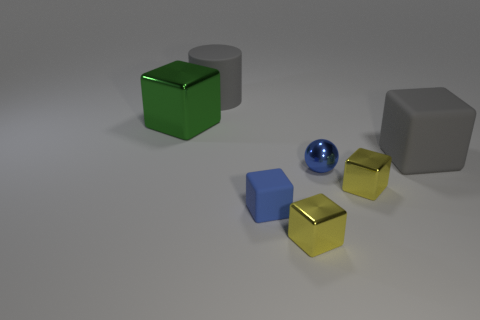What is the material of the gray cylinder that is the same size as the gray block?
Offer a terse response. Rubber. What number of other things are made of the same material as the tiny blue sphere?
Provide a short and direct response. 3. Is the number of yellow shiny cubes that are behind the big shiny cube less than the number of large cylinders?
Your answer should be compact. Yes. Is the shape of the tiny matte object the same as the large shiny thing?
Your response must be concise. Yes. How big is the object that is behind the block that is on the left side of the big gray matte object on the left side of the large gray rubber cube?
Offer a very short reply. Large. What is the material of the other big object that is the same shape as the big green object?
Offer a very short reply. Rubber. Is there anything else that is the same size as the ball?
Provide a short and direct response. Yes. What size is the gray matte object that is on the right side of the large gray thing that is behind the big green metallic object?
Your answer should be very brief. Large. What is the color of the small sphere?
Give a very brief answer. Blue. What number of blue things are behind the small blue object on the left side of the blue metallic thing?
Make the answer very short. 1. 